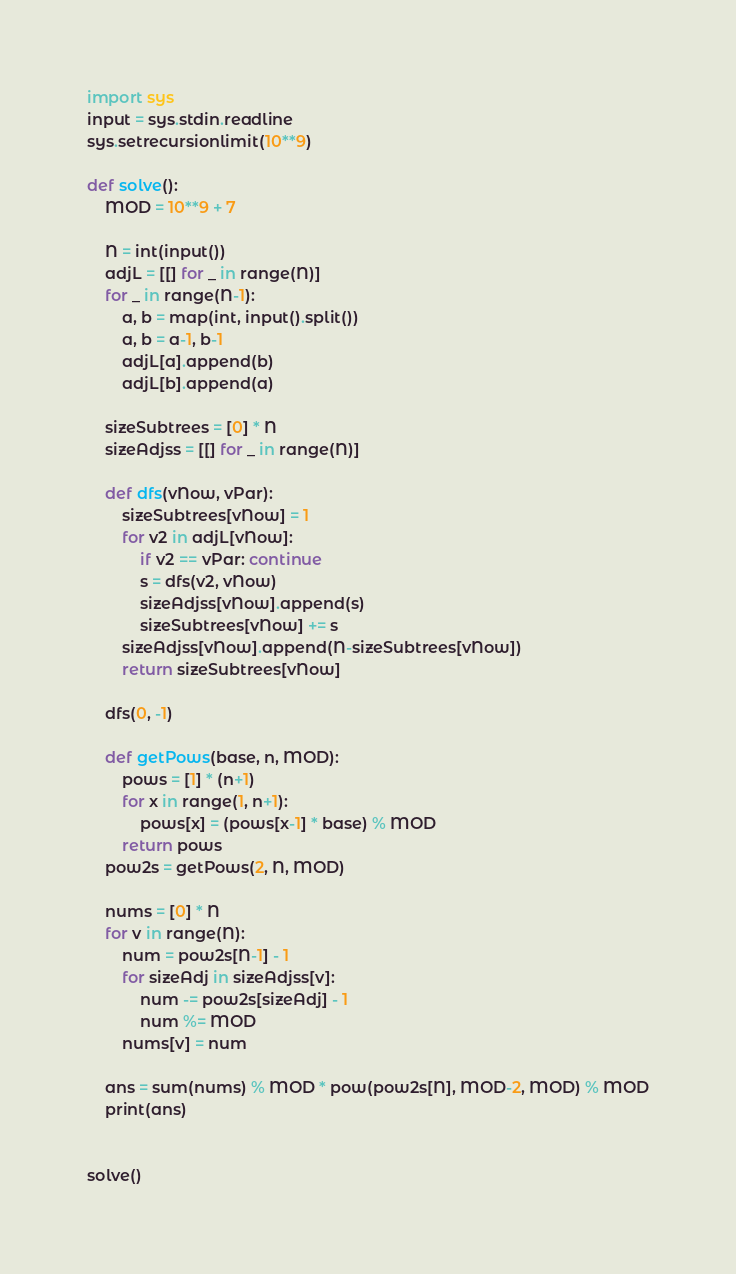Convert code to text. <code><loc_0><loc_0><loc_500><loc_500><_Python_>import sys
input = sys.stdin.readline
sys.setrecursionlimit(10**9)

def solve():
    MOD = 10**9 + 7

    N = int(input())
    adjL = [[] for _ in range(N)]
    for _ in range(N-1):
        a, b = map(int, input().split())
        a, b = a-1, b-1
        adjL[a].append(b)
        adjL[b].append(a)

    sizeSubtrees = [0] * N
    sizeAdjss = [[] for _ in range(N)]

    def dfs(vNow, vPar):
        sizeSubtrees[vNow] = 1
        for v2 in adjL[vNow]:
            if v2 == vPar: continue
            s = dfs(v2, vNow)
            sizeAdjss[vNow].append(s)
            sizeSubtrees[vNow] += s
        sizeAdjss[vNow].append(N-sizeSubtrees[vNow])
        return sizeSubtrees[vNow]

    dfs(0, -1)

    def getPows(base, n, MOD):
        pows = [1] * (n+1)
        for x in range(1, n+1):
            pows[x] = (pows[x-1] * base) % MOD
        return pows
    pow2s = getPows(2, N, MOD)

    nums = [0] * N
    for v in range(N):
        num = pow2s[N-1] - 1
        for sizeAdj in sizeAdjss[v]:
            num -= pow2s[sizeAdj] - 1
            num %= MOD
        nums[v] = num

    ans = sum(nums) % MOD * pow(pow2s[N], MOD-2, MOD) % MOD
    print(ans)


solve()
</code> 